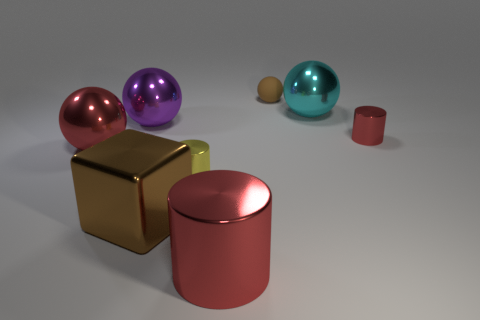Subtract all yellow balls. Subtract all gray cubes. How many balls are left? 4 Add 2 small brown balls. How many objects exist? 10 Subtract all cubes. How many objects are left? 7 Subtract 1 red balls. How many objects are left? 7 Subtract all large red things. Subtract all large cyan spheres. How many objects are left? 5 Add 4 blocks. How many blocks are left? 5 Add 6 big purple metal objects. How many big purple metal objects exist? 7 